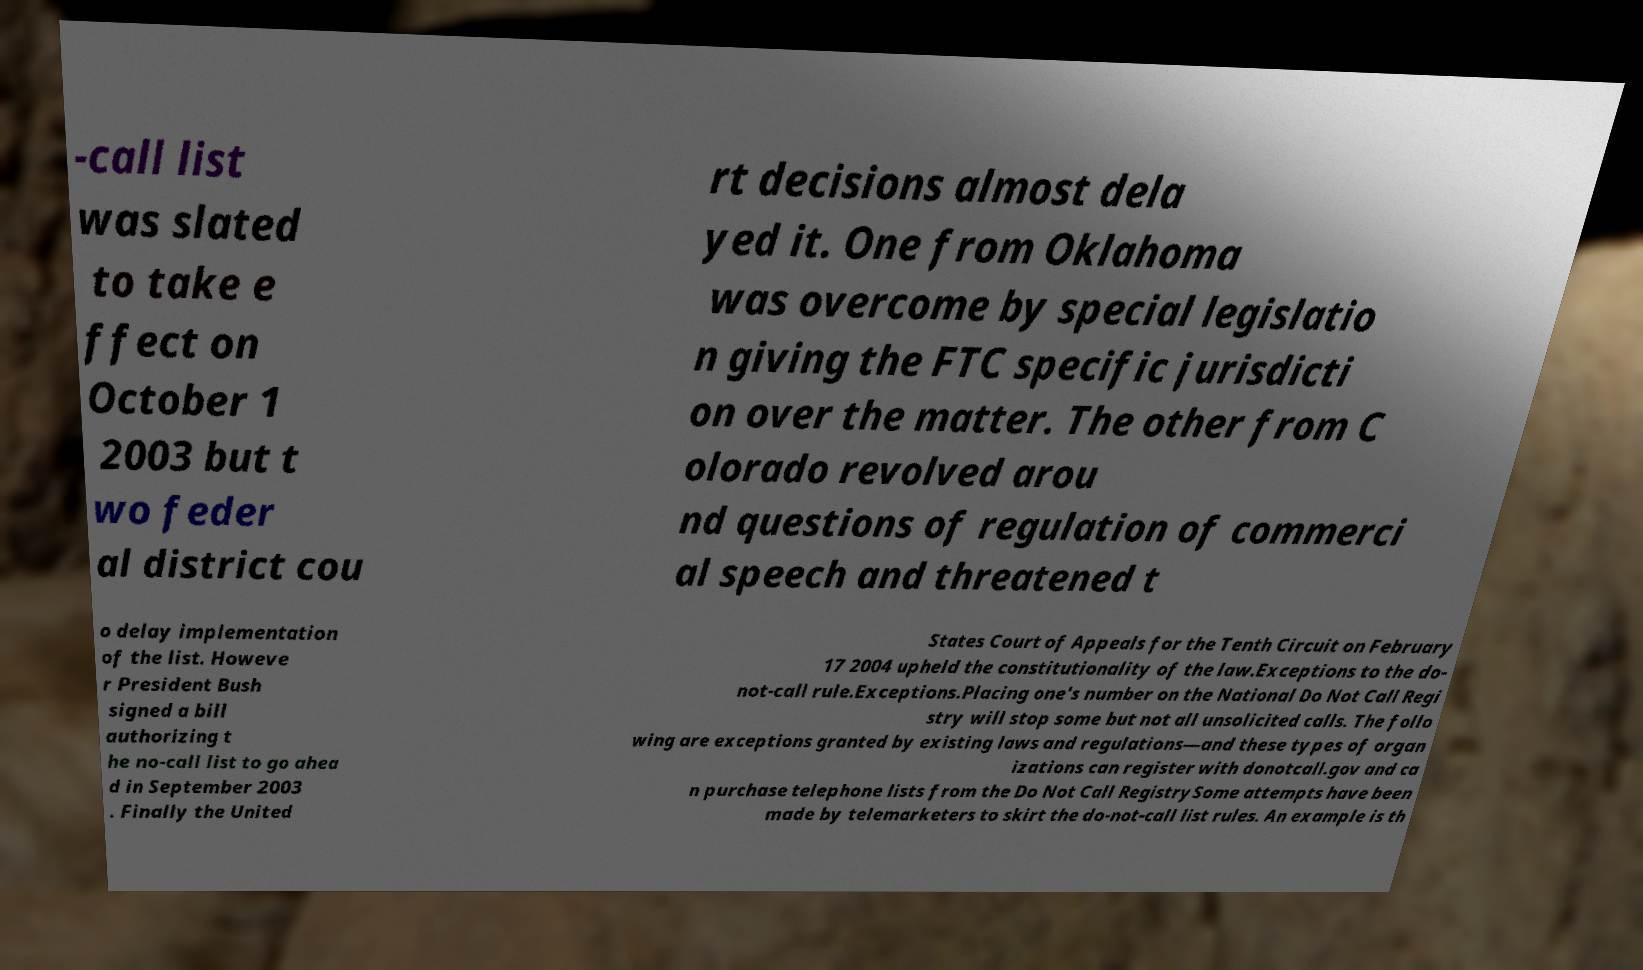Please read and relay the text visible in this image. What does it say? -call list was slated to take e ffect on October 1 2003 but t wo feder al district cou rt decisions almost dela yed it. One from Oklahoma was overcome by special legislatio n giving the FTC specific jurisdicti on over the matter. The other from C olorado revolved arou nd questions of regulation of commerci al speech and threatened t o delay implementation of the list. Howeve r President Bush signed a bill authorizing t he no-call list to go ahea d in September 2003 . Finally the United States Court of Appeals for the Tenth Circuit on February 17 2004 upheld the constitutionality of the law.Exceptions to the do- not-call rule.Exceptions.Placing one's number on the National Do Not Call Regi stry will stop some but not all unsolicited calls. The follo wing are exceptions granted by existing laws and regulations—and these types of organ izations can register with donotcall.gov and ca n purchase telephone lists from the Do Not Call RegistrySome attempts have been made by telemarketers to skirt the do-not-call list rules. An example is th 